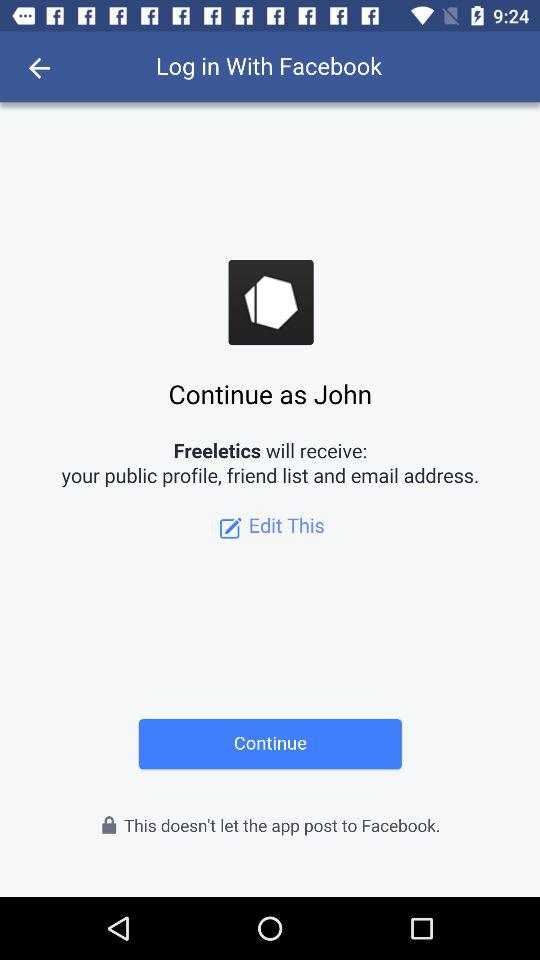What application is asking for permission? The application asking for permission is "Freeletics". 